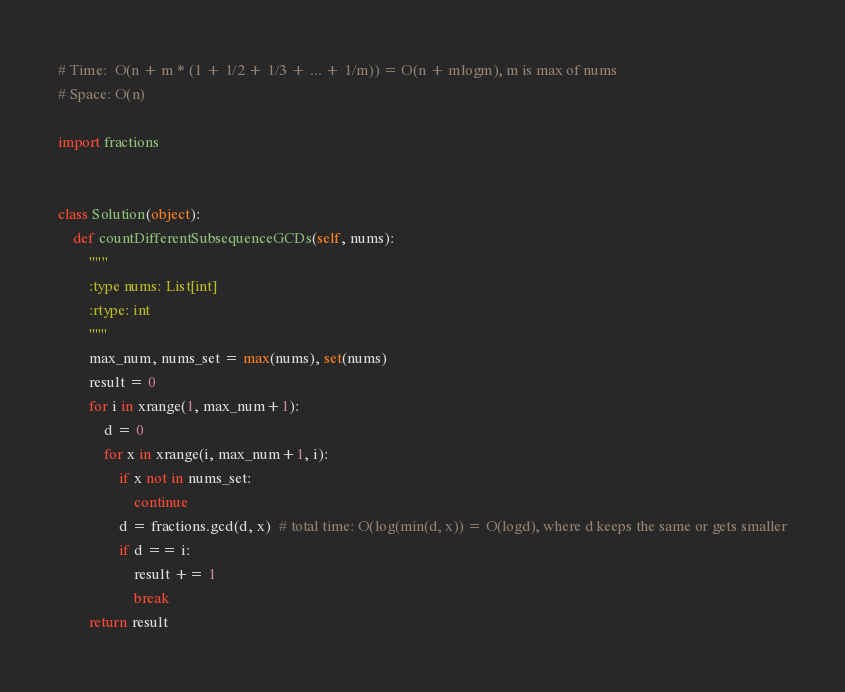<code> <loc_0><loc_0><loc_500><loc_500><_Python_># Time:  O(n + m * (1 + 1/2 + 1/3 + ... + 1/m)) = O(n + mlogm), m is max of nums
# Space: O(n)

import fractions


class Solution(object):
    def countDifferentSubsequenceGCDs(self, nums):
        """
        :type nums: List[int]
        :rtype: int
        """
        max_num, nums_set = max(nums), set(nums)
        result = 0
        for i in xrange(1, max_num+1):
            d = 0
            for x in xrange(i, max_num+1, i):
                if x not in nums_set:
                    continue
                d = fractions.gcd(d, x)  # total time: O(log(min(d, x)) = O(logd), where d keeps the same or gets smaller
                if d == i:
                    result += 1
                    break
        return result
</code> 